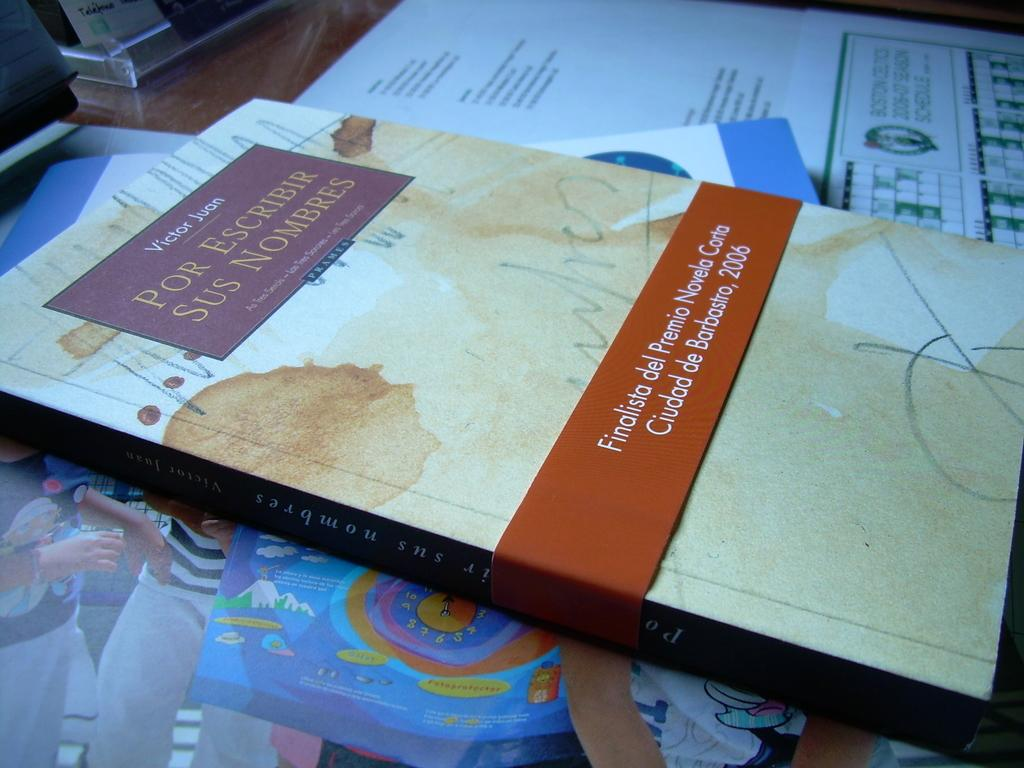<image>
Create a compact narrative representing the image presented. The author of the book laying on the desk is Victor Juan. 